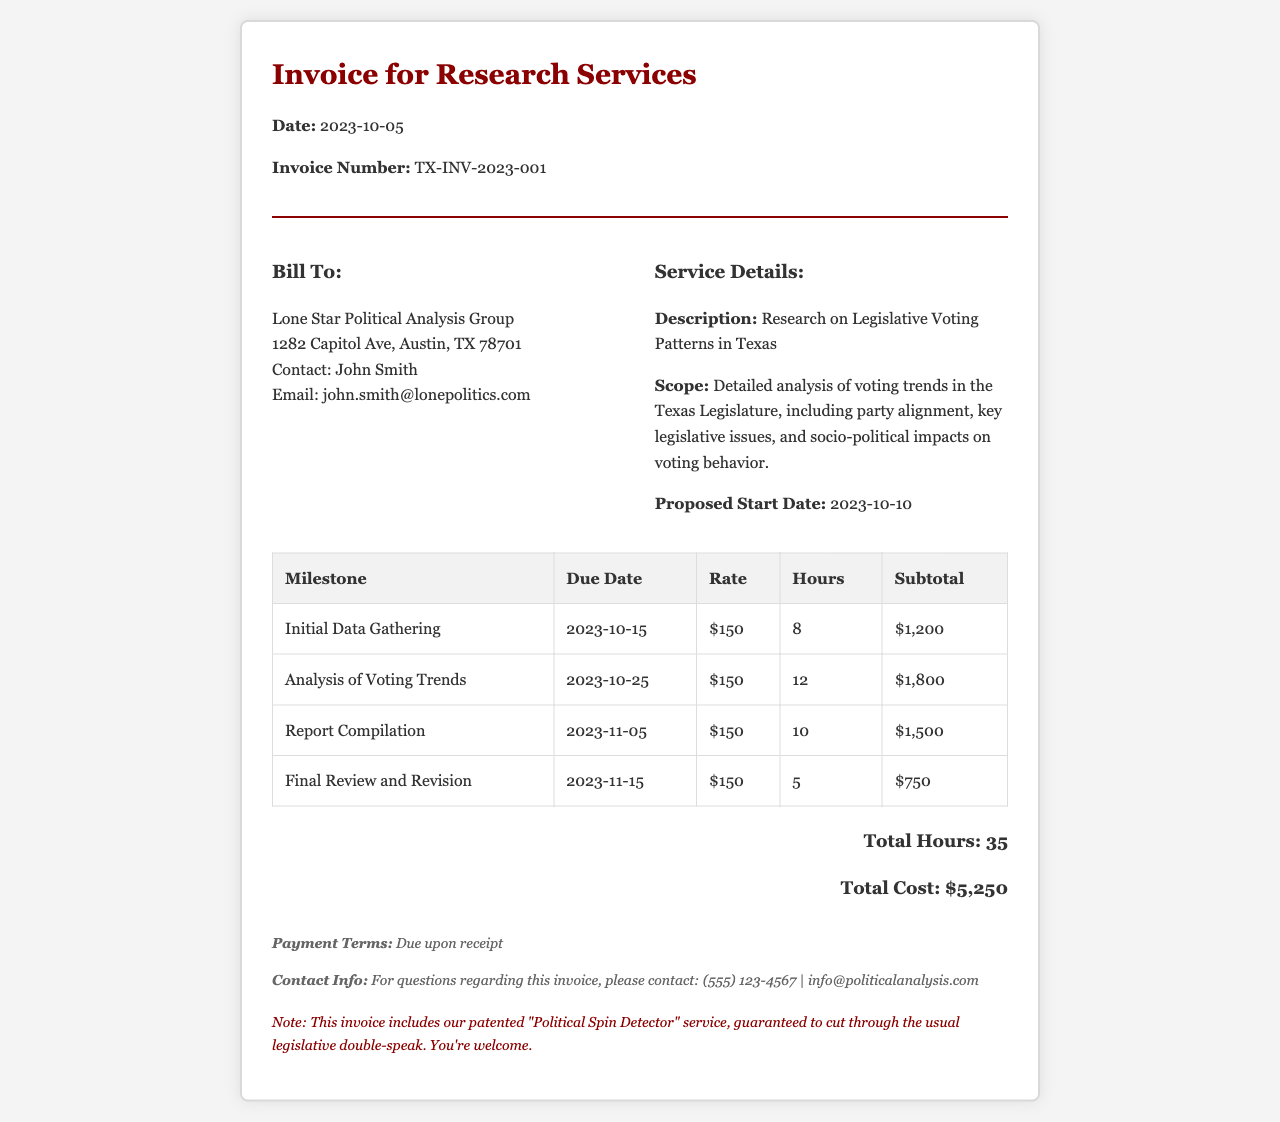what is the date of the invoice? The date of the invoice is indicated near the header of the document.
Answer: 2023-10-05 who is the client for this invoice? The client's information is located in the "Bill To" section of the document.
Answer: Lone Star Political Analysis Group how many total hours are billed in the invoice? The total hours are summarized at the bottom of the invoice.
Answer: 35 what is the subtotal for the "Report Compilation" milestone? The subtotal for this milestone is found in the corresponding row of the detailed table.
Answer: $1,500 what is the proposed start date for the project? The proposed start date is listed in the "Service Details" section.
Answer: 2023-10-10 how much is the hourly rate for the services provided? The hourly rate is provided in each row of the milestone table.
Answer: $150 what is the total cost for the research services? The total cost is summarized at the bottom of the invoice.
Answer: $5,250 what is the due date for the “Final Review and Revision” milestone? The due date for this milestone is found in the milestone table.
Answer: 2023-11-15 what are the payment terms listed in the invoice? The payment terms are mentioned in the "Terms" section of the document.
Answer: Due upon receipt 